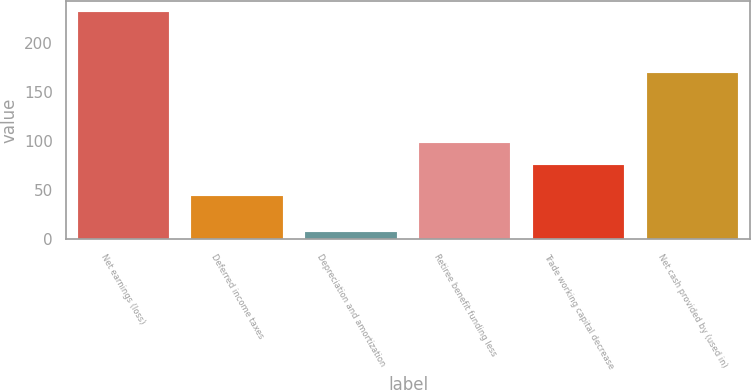Convert chart to OTSL. <chart><loc_0><loc_0><loc_500><loc_500><bar_chart><fcel>Net earnings (loss)<fcel>Deferred income taxes<fcel>Depreciation and amortization<fcel>Retiree benefit funding less<fcel>Trade working capital decrease<fcel>Net cash provided by (used in)<nl><fcel>231<fcel>44<fcel>7<fcel>98.4<fcel>76<fcel>169<nl></chart> 